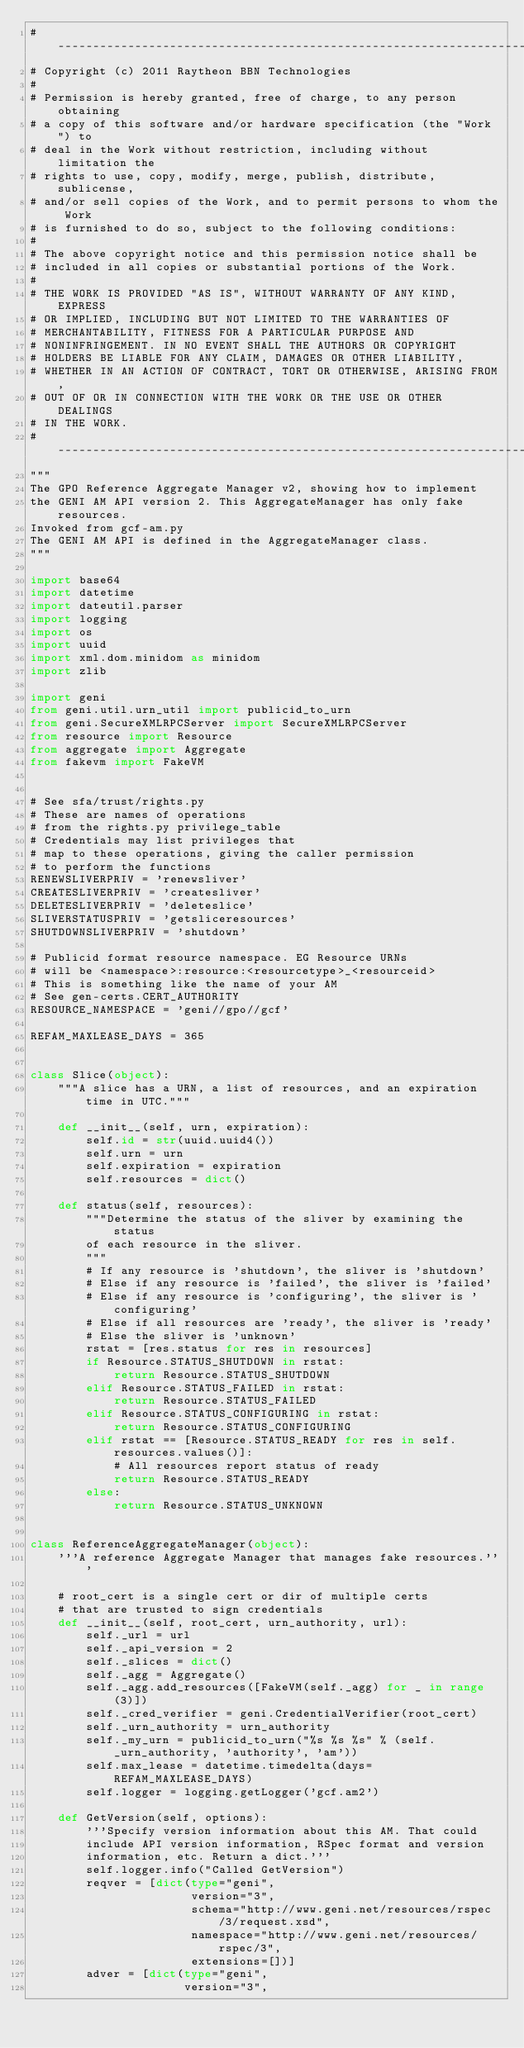<code> <loc_0><loc_0><loc_500><loc_500><_Python_>#----------------------------------------------------------------------
# Copyright (c) 2011 Raytheon BBN Technologies
#
# Permission is hereby granted, free of charge, to any person obtaining
# a copy of this software and/or hardware specification (the "Work") to
# deal in the Work without restriction, including without limitation the
# rights to use, copy, modify, merge, publish, distribute, sublicense,
# and/or sell copies of the Work, and to permit persons to whom the Work
# is furnished to do so, subject to the following conditions:
#
# The above copyright notice and this permission notice shall be
# included in all copies or substantial portions of the Work.
#
# THE WORK IS PROVIDED "AS IS", WITHOUT WARRANTY OF ANY KIND, EXPRESS
# OR IMPLIED, INCLUDING BUT NOT LIMITED TO THE WARRANTIES OF
# MERCHANTABILITY, FITNESS FOR A PARTICULAR PURPOSE AND
# NONINFRINGEMENT. IN NO EVENT SHALL THE AUTHORS OR COPYRIGHT
# HOLDERS BE LIABLE FOR ANY CLAIM, DAMAGES OR OTHER LIABILITY,
# WHETHER IN AN ACTION OF CONTRACT, TORT OR OTHERWISE, ARISING FROM,
# OUT OF OR IN CONNECTION WITH THE WORK OR THE USE OR OTHER DEALINGS
# IN THE WORK.
#----------------------------------------------------------------------
"""
The GPO Reference Aggregate Manager v2, showing how to implement
the GENI AM API version 2. This AggregateManager has only fake resources.
Invoked from gcf-am.py
The GENI AM API is defined in the AggregateManager class.
"""

import base64
import datetime
import dateutil.parser
import logging
import os
import uuid
import xml.dom.minidom as minidom
import zlib

import geni
from geni.util.urn_util import publicid_to_urn
from geni.SecureXMLRPCServer import SecureXMLRPCServer
from resource import Resource
from aggregate import Aggregate
from fakevm import FakeVM


# See sfa/trust/rights.py
# These are names of operations
# from the rights.py privilege_table
# Credentials may list privileges that
# map to these operations, giving the caller permission
# to perform the functions
RENEWSLIVERPRIV = 'renewsliver'
CREATESLIVERPRIV = 'createsliver'
DELETESLIVERPRIV = 'deleteslice'
SLIVERSTATUSPRIV = 'getsliceresources'
SHUTDOWNSLIVERPRIV = 'shutdown'

# Publicid format resource namespace. EG Resource URNs
# will be <namespace>:resource:<resourcetype>_<resourceid>
# This is something like the name of your AM
# See gen-certs.CERT_AUTHORITY
RESOURCE_NAMESPACE = 'geni//gpo//gcf'

REFAM_MAXLEASE_DAYS = 365


class Slice(object):
    """A slice has a URN, a list of resources, and an expiration time in UTC."""

    def __init__(self, urn, expiration):
        self.id = str(uuid.uuid4())
        self.urn = urn
        self.expiration = expiration
        self.resources = dict()

    def status(self, resources):
        """Determine the status of the sliver by examining the status
        of each resource in the sliver.
        """
        # If any resource is 'shutdown', the sliver is 'shutdown'
        # Else if any resource is 'failed', the sliver is 'failed'
        # Else if any resource is 'configuring', the sliver is 'configuring'
        # Else if all resources are 'ready', the sliver is 'ready'
        # Else the sliver is 'unknown'
        rstat = [res.status for res in resources]
        if Resource.STATUS_SHUTDOWN in rstat:
            return Resource.STATUS_SHUTDOWN
        elif Resource.STATUS_FAILED in rstat:
            return Resource.STATUS_FAILED
        elif Resource.STATUS_CONFIGURING in rstat:
            return Resource.STATUS_CONFIGURING
        elif rstat == [Resource.STATUS_READY for res in self.resources.values()]:
            # All resources report status of ready
            return Resource.STATUS_READY
        else:
            return Resource.STATUS_UNKNOWN


class ReferenceAggregateManager(object):
    '''A reference Aggregate Manager that manages fake resources.'''

    # root_cert is a single cert or dir of multiple certs
    # that are trusted to sign credentials
    def __init__(self, root_cert, urn_authority, url):
        self._url = url
        self._api_version = 2
        self._slices = dict()
        self._agg = Aggregate()
        self._agg.add_resources([FakeVM(self._agg) for _ in range(3)])
        self._cred_verifier = geni.CredentialVerifier(root_cert)
        self._urn_authority = urn_authority
        self._my_urn = publicid_to_urn("%s %s %s" % (self._urn_authority, 'authority', 'am'))
        self.max_lease = datetime.timedelta(days=REFAM_MAXLEASE_DAYS)
        self.logger = logging.getLogger('gcf.am2')

    def GetVersion(self, options):
        '''Specify version information about this AM. That could
        include API version information, RSpec format and version
        information, etc. Return a dict.'''
        self.logger.info("Called GetVersion")
        reqver = [dict(type="geni",
                       version="3",
                       schema="http://www.geni.net/resources/rspec/3/request.xsd",
                       namespace="http://www.geni.net/resources/rspec/3",
                       extensions=[])]
        adver = [dict(type="geni",
                      version="3",</code> 